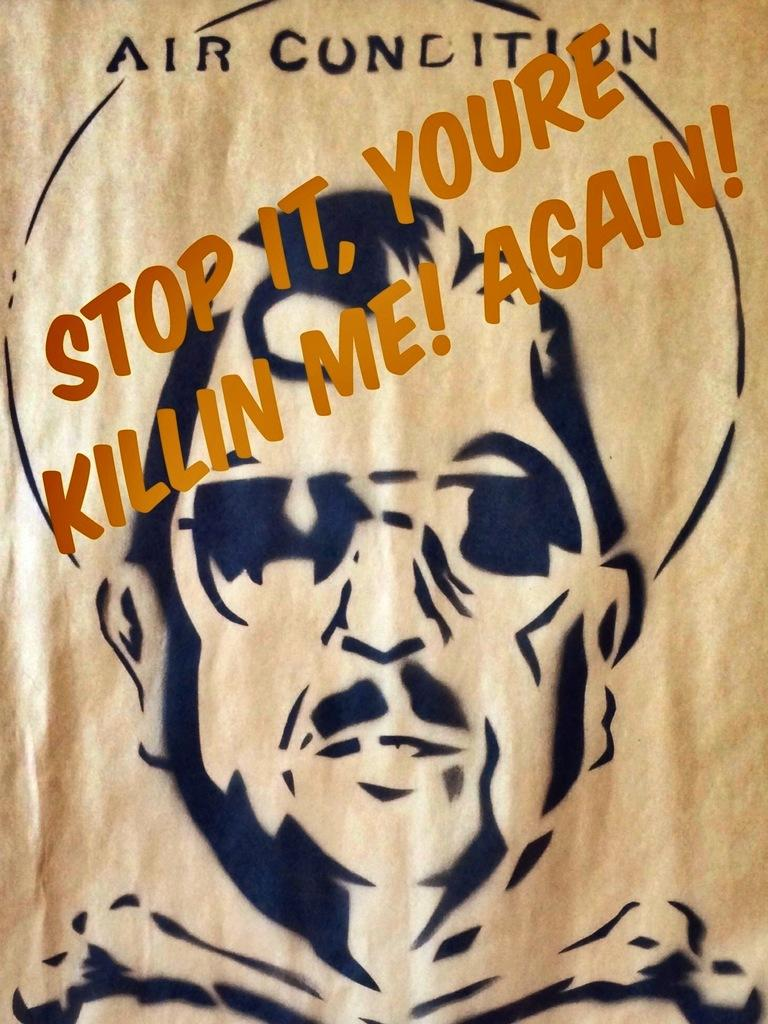What is the main subject of the image? There is a sketch in the image. What type of advice can be seen in the sketch? There is no advice present in the sketch; it is a visual representation and does not contain any text or spoken words. 